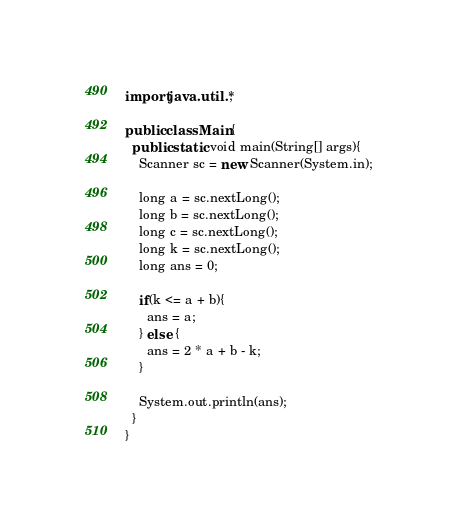<code> <loc_0><loc_0><loc_500><loc_500><_Java_>import java.util.*;

public class Main{
  public static void main(String[] args){
    Scanner sc = new Scanner(System.in);

    long a = sc.nextLong();
    long b = sc.nextLong();
    long c = sc.nextLong();
    long k = sc.nextLong();
    long ans = 0;

    if(k <= a + b){
      ans = a;
    } else {
      ans = 2 * a + b - k;
    }

    System.out.println(ans);
  }
}
</code> 